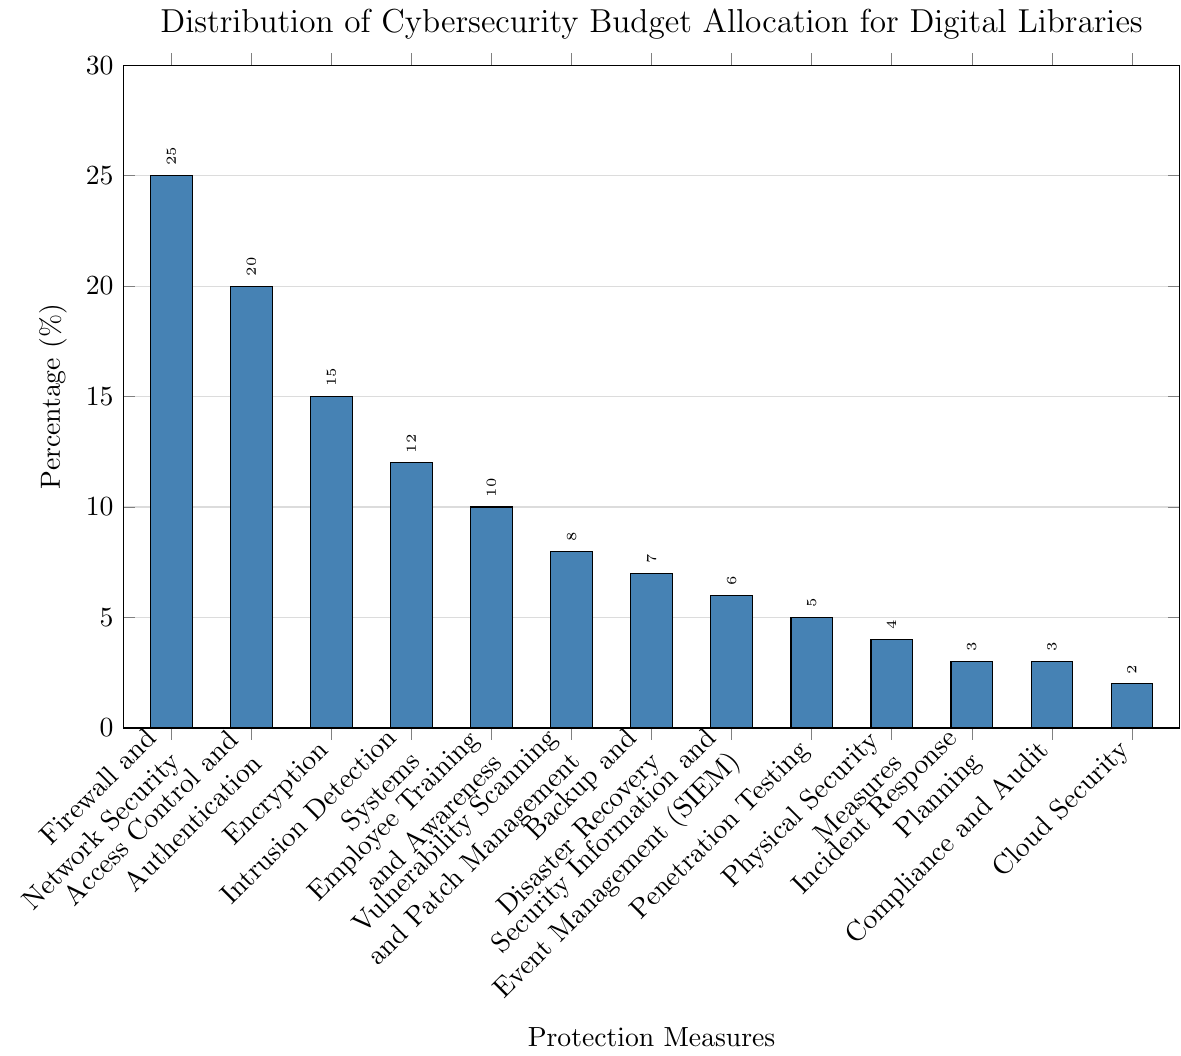What is the highest percentage allocation in the budget, and which category does it belong to? The highest percentage can be identified by looking at the tallest bar in the bar chart. The tallest bar corresponds to "Firewall and Network Security" which has a percentage of 25%
Answer: Firewall and Network Security, 25% Which category has the lowest budget allocation, and what is its percentage? The shortest bar in the bar chart represents the category with the lowest budget allocation. "Cloud Security" has the shortest bar with a percentage of 2%
Answer: Cloud Security, 2% What is the total budget allocation percentage for Access Control and Authentication and Encryption combined? To find the total allocation, add the percentages of "Access Control and Authentication" and "Encryption". They are 20% and 15%, respectively. So, 20 + 15 = 35%
Answer: 35% What is the difference in budget allocation between Vulnerability Scanning and Patch Management and Employee Training and Awareness? To determine the difference, subtract the percentage of "Employee Training and Awareness" from "Vulnerability Scanning and Patch Management". So, 10% - 8% = 2%
Answer: 2% If the budget for Backup and Disaster Recovery was doubled, what would its new percentage be and would it surpass any other categories? Currently, Backup and Disaster Recovery has 7%. Doubling this would be 7 * 2 = 14%. It would surpass "Intrusion Detection Systems" (12%) and fall below "Encryption" (15%)
Answer: 14%, no, but surpass Intrusion Detection Systems Which categories have a budget allocation percentage greater than 10%? Categories with bar lengths extending above the 10% mark on the y-axis are: "Firewall and Network Security" (25%), "Access Control and Authentication" (20%), "Encryption" (15%), "Intrusion Detection Systems" (12%), and "Employee Training and Awareness" (10%)
Answer: Firewall and Network Security, Access Control and Authentication, Encryption, Intrusion Detection Systems What is the sum of the budget allocations for Intrusion Detection Systems, Employee Training and Awareness, and Vulnerability Scanning and Patch Management? Adding the percentages of these three categories results in: Intrusion Detection Systems (12%) + Employee Training and Awareness (10%) + Vulnerability Scanning and Patch Management (8%) = 12 + 10 + 8 = 30%
Answer: 30% Does any single category account for more than a quarter of the total budget? A quarter of the total budget is 25%. "Firewall and Network Security" has exactly 25% of the budget, no category exceeds this value
Answer: No Are there more categories with budget allocations below 10% or above 10%? Counting the categories: Below 10% are 7 categories (45 + 7 + 6 + 5 + 4 + 3 + 3 + 2) and above 10% are 5 categories (25 + 20 + 15 + 12 + 10). There are more categories below 10%
Answer: Below 10% Which category has a percentage allocation exactly equal to 5%, and how does its bar height visually compare to the bar for Compliance and Audit? "Penetration Testing" has a percentage allocation of 5%. Visually, its bar is slightly taller than the bar for "Compliance and Audit" which has 3%
Answer: Penetration Testing, slightly taller 